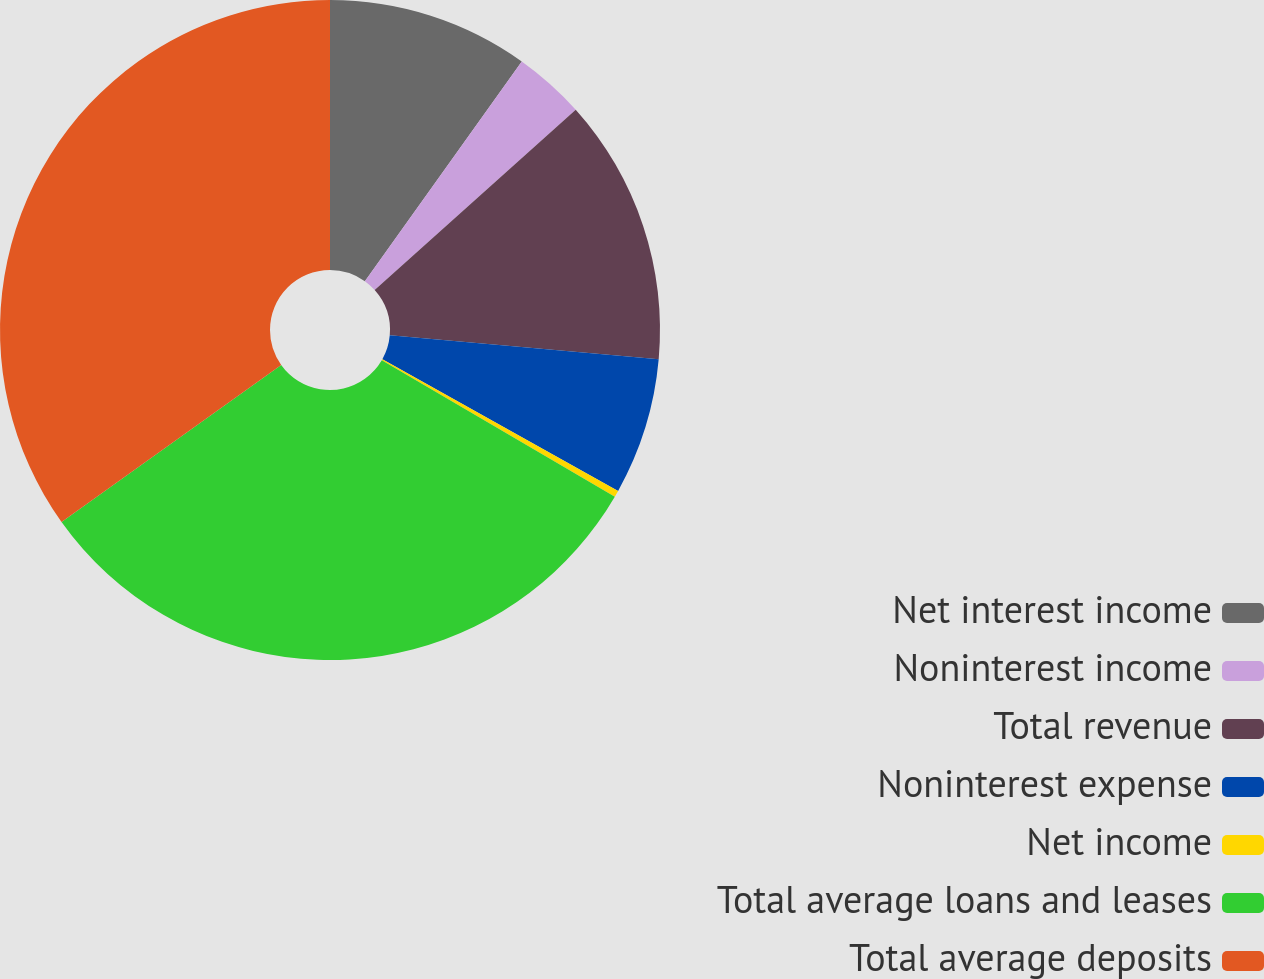Convert chart to OTSL. <chart><loc_0><loc_0><loc_500><loc_500><pie_chart><fcel>Net interest income<fcel>Noninterest income<fcel>Total revenue<fcel>Noninterest expense<fcel>Net income<fcel>Total average loans and leases<fcel>Total average deposits<nl><fcel>9.87%<fcel>3.5%<fcel>13.05%<fcel>6.69%<fcel>0.32%<fcel>31.7%<fcel>34.88%<nl></chart> 